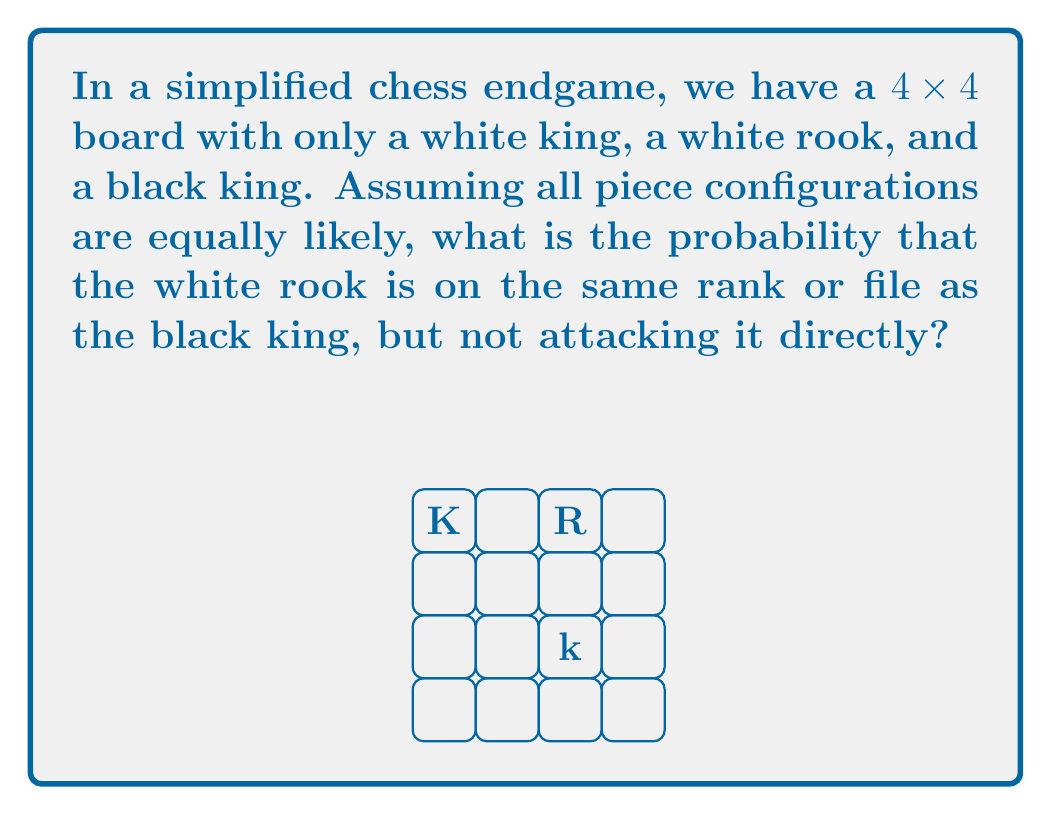Can you solve this math problem? Let's approach this step-by-step:

1) First, we need to calculate the total number of possible configurations:
   - The white king can be on any of the 16 squares: 16 choices
   - For each white king position, the black king can be on any of the remaining 15 squares: 15 choices
   - For each arrangement of kings, the rook can be on any of the remaining 14 squares: 14 choices
   - Total configurations: $16 \times 15 \times 14 = 3360$

2) Now, let's count the favorable configurations:
   - The black king can be on any of the 16 squares: 16 choices
   - For each black king position, we need to count rook positions that are on the same rank or file, but not attacking:
     - On the same rank: 2 squares (3 squares in the rank, minus 1 for direct attack)
     - On the same file: 2 squares (3 squares in the file, minus 1 for direct attack)
   - So for each black king position, there are 4 favorable rook positions
   - The white king can be on any of the remaining 14 squares: 14 choices
   - Favorable configurations: $16 \times 4 \times 14 = 896$

3) The probability is then:

   $$P = \frac{\text{Favorable configurations}}{\text{Total configurations}} = \frac{896}{3360} = \frac{4}{15} \approx 0.2667$$
Answer: $\frac{4}{15}$ 